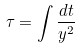<formula> <loc_0><loc_0><loc_500><loc_500>\tau = \int \frac { d t } { y ^ { 2 } }</formula> 